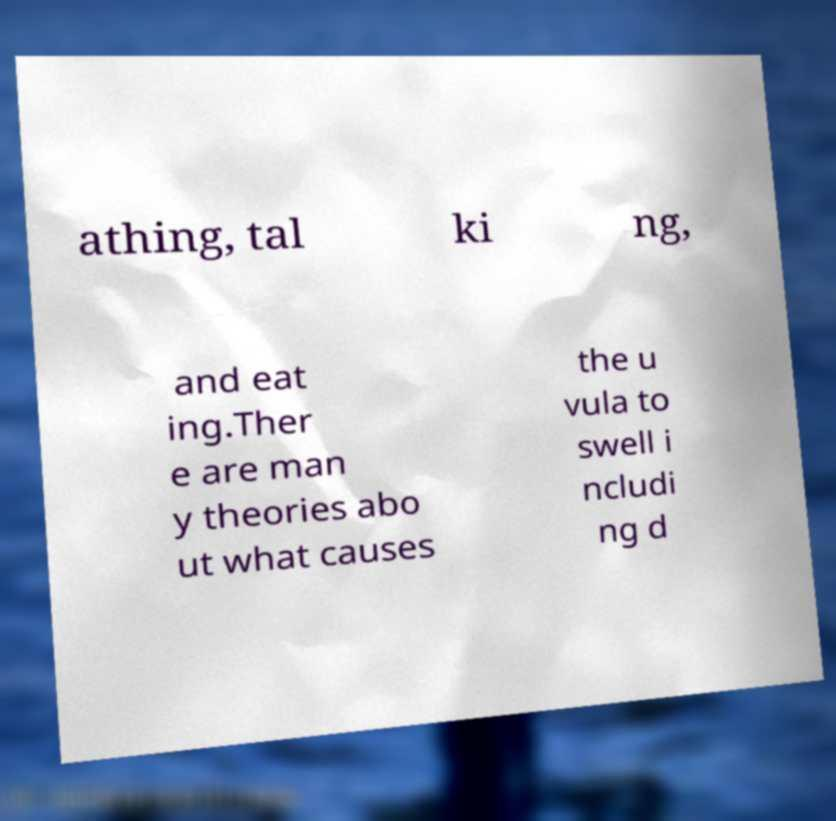Could you assist in decoding the text presented in this image and type it out clearly? athing, tal ki ng, and eat ing.Ther e are man y theories abo ut what causes the u vula to swell i ncludi ng d 